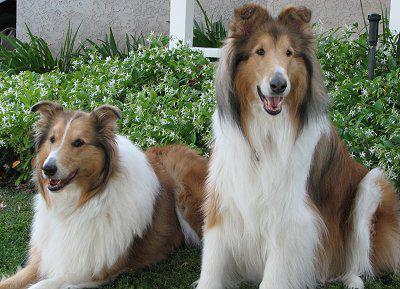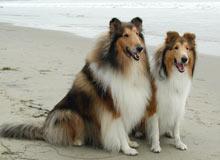The first image is the image on the left, the second image is the image on the right. Examine the images to the left and right. Is the description "Two Collies beside each other have their heads cocked to the right." accurate? Answer yes or no. No. The first image is the image on the left, the second image is the image on the right. Assess this claim about the two images: "There are at most five dogs.". Correct or not? Answer yes or no. Yes. 